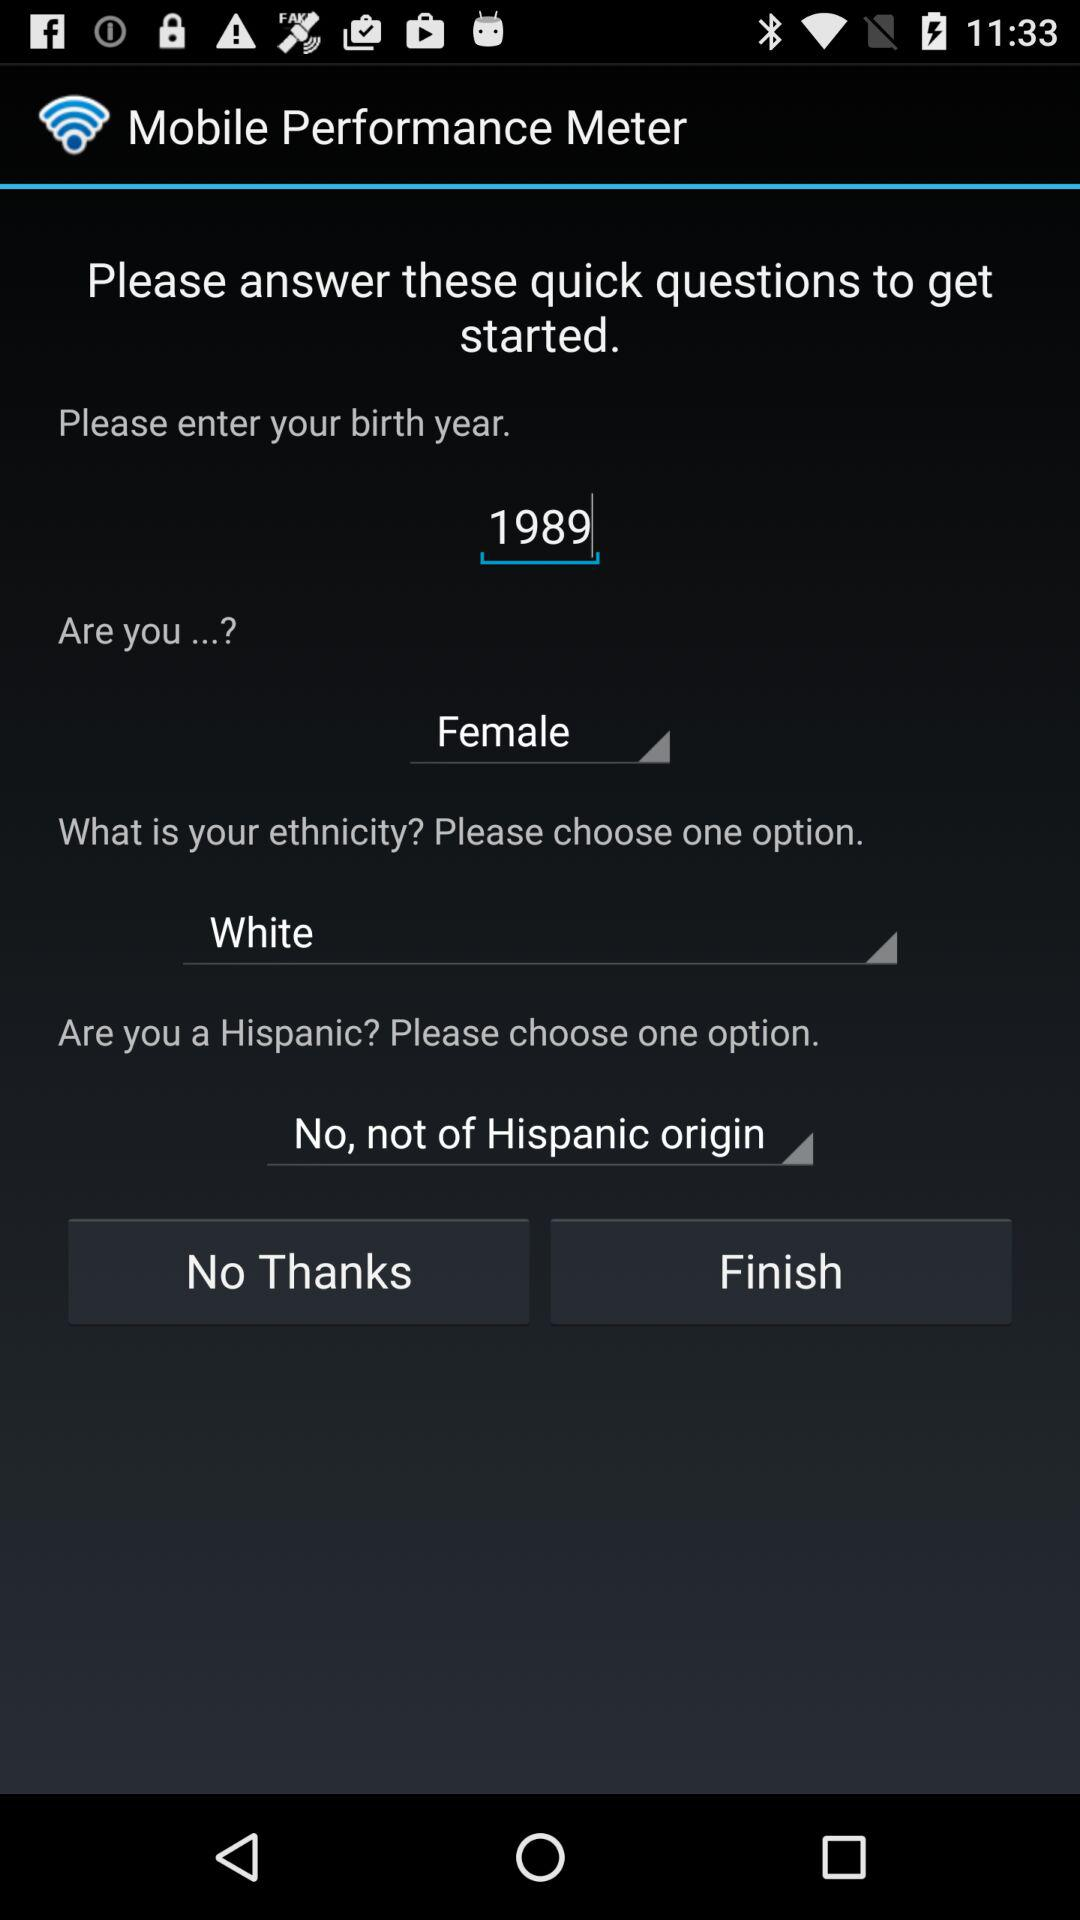What is the name of the application? The name of the application is "Mobile Performance Meter". 